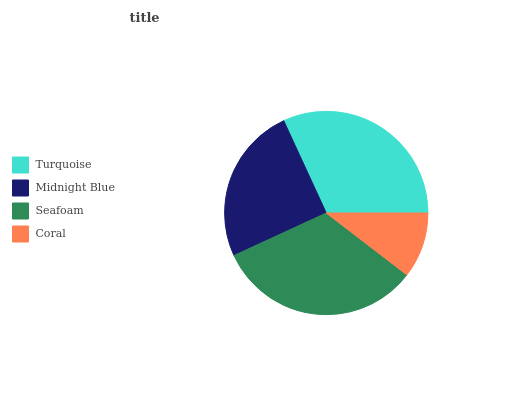Is Coral the minimum?
Answer yes or no. Yes. Is Seafoam the maximum?
Answer yes or no. Yes. Is Midnight Blue the minimum?
Answer yes or no. No. Is Midnight Blue the maximum?
Answer yes or no. No. Is Turquoise greater than Midnight Blue?
Answer yes or no. Yes. Is Midnight Blue less than Turquoise?
Answer yes or no. Yes. Is Midnight Blue greater than Turquoise?
Answer yes or no. No. Is Turquoise less than Midnight Blue?
Answer yes or no. No. Is Turquoise the high median?
Answer yes or no. Yes. Is Midnight Blue the low median?
Answer yes or no. Yes. Is Coral the high median?
Answer yes or no. No. Is Coral the low median?
Answer yes or no. No. 